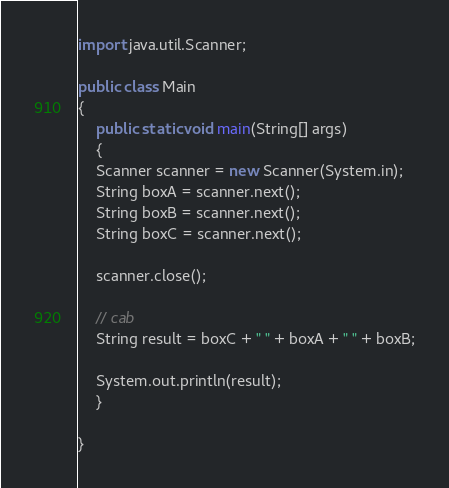Convert code to text. <code><loc_0><loc_0><loc_500><loc_500><_Java_>import java.util.Scanner;

public class Main
{
    public static void main(String[] args)
    {
	Scanner scanner = new Scanner(System.in);
	String boxA = scanner.next();
	String boxB = scanner.next();
	String boxC = scanner.next();

	scanner.close();

	// cab
	String result = boxC + " " + boxA + " " + boxB;

	System.out.println(result);
    }

}</code> 